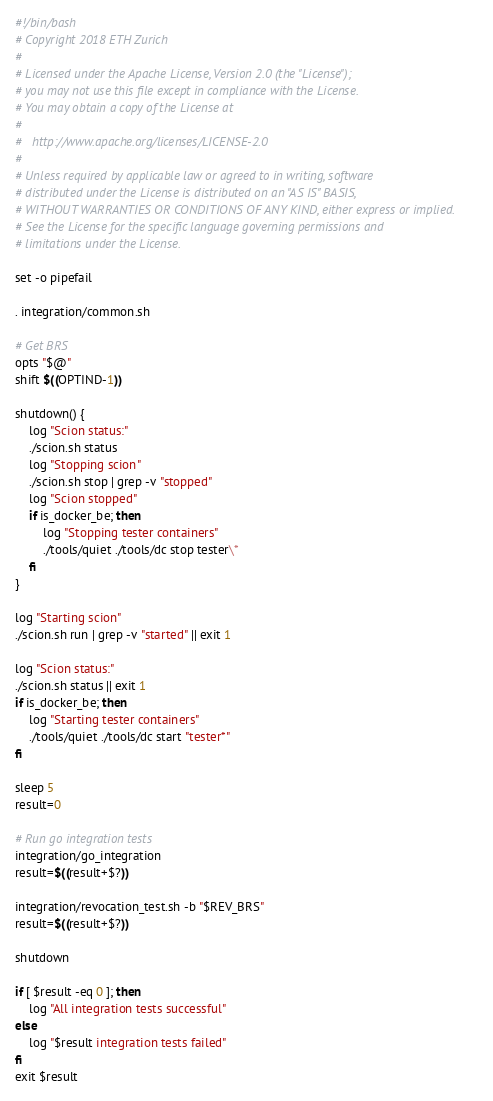Convert code to text. <code><loc_0><loc_0><loc_500><loc_500><_Bash_>#!/bin/bash
# Copyright 2018 ETH Zurich
#
# Licensed under the Apache License, Version 2.0 (the "License");
# you may not use this file except in compliance with the License.
# You may obtain a copy of the License at
#
#   http://www.apache.org/licenses/LICENSE-2.0
#
# Unless required by applicable law or agreed to in writing, software
# distributed under the License is distributed on an "AS IS" BASIS,
# WITHOUT WARRANTIES OR CONDITIONS OF ANY KIND, either express or implied.
# See the License for the specific language governing permissions and
# limitations under the License.

set -o pipefail

. integration/common.sh

# Get BRS
opts "$@"
shift $((OPTIND-1))

shutdown() {
    log "Scion status:"
    ./scion.sh status
    log "Stopping scion"
    ./scion.sh stop | grep -v "stopped"
    log "Scion stopped"
    if is_docker_be; then
        log "Stopping tester containers"
        ./tools/quiet ./tools/dc stop tester\*
    fi
}

log "Starting scion"
./scion.sh run | grep -v "started" || exit 1

log "Scion status:"
./scion.sh status || exit 1
if is_docker_be; then
    log "Starting tester containers"
    ./tools/quiet ./tools/dc start "tester*"
fi

sleep 5
result=0

# Run go integration tests
integration/go_integration
result=$((result+$?))

integration/revocation_test.sh -b "$REV_BRS"
result=$((result+$?))

shutdown

if [ $result -eq 0 ]; then
    log "All integration tests successful"
else
    log "$result integration tests failed"
fi
exit $result
</code> 